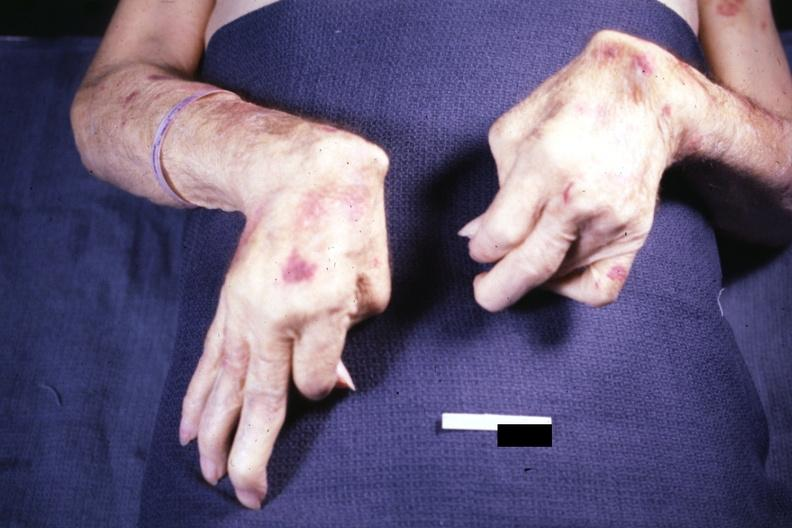s hand present?
Answer the question using a single word or phrase. Yes 